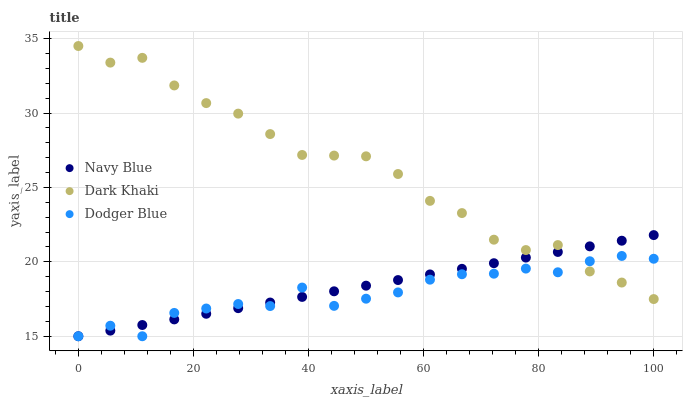Does Dodger Blue have the minimum area under the curve?
Answer yes or no. Yes. Does Dark Khaki have the maximum area under the curve?
Answer yes or no. Yes. Does Navy Blue have the minimum area under the curve?
Answer yes or no. No. Does Navy Blue have the maximum area under the curve?
Answer yes or no. No. Is Navy Blue the smoothest?
Answer yes or no. Yes. Is Dark Khaki the roughest?
Answer yes or no. Yes. Is Dodger Blue the smoothest?
Answer yes or no. No. Is Dodger Blue the roughest?
Answer yes or no. No. Does Navy Blue have the lowest value?
Answer yes or no. Yes. Does Dark Khaki have the highest value?
Answer yes or no. Yes. Does Navy Blue have the highest value?
Answer yes or no. No. Does Dodger Blue intersect Navy Blue?
Answer yes or no. Yes. Is Dodger Blue less than Navy Blue?
Answer yes or no. No. Is Dodger Blue greater than Navy Blue?
Answer yes or no. No. 